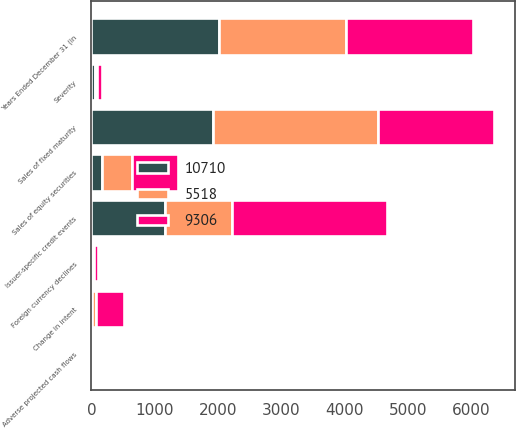Convert chart. <chart><loc_0><loc_0><loc_500><loc_500><stacked_bar_chart><ecel><fcel>Years Ended December 31 (in<fcel>Sales of fixed maturity<fcel>Sales of equity securities<fcel>Severity<fcel>Change in intent<fcel>Foreign currency declines<fcel>Issuer-specific credit events<fcel>Adverse projected cash flows<nl><fcel>5518<fcel>2012<fcel>2607<fcel>484<fcel>44<fcel>62<fcel>8<fcel>1048<fcel>5<nl><fcel>10710<fcel>2011<fcel>1913<fcel>164<fcel>51<fcel>12<fcel>32<fcel>1165<fcel>20<nl><fcel>9306<fcel>2010<fcel>1846<fcel>725<fcel>73<fcel>441<fcel>63<fcel>2457<fcel>5<nl></chart> 